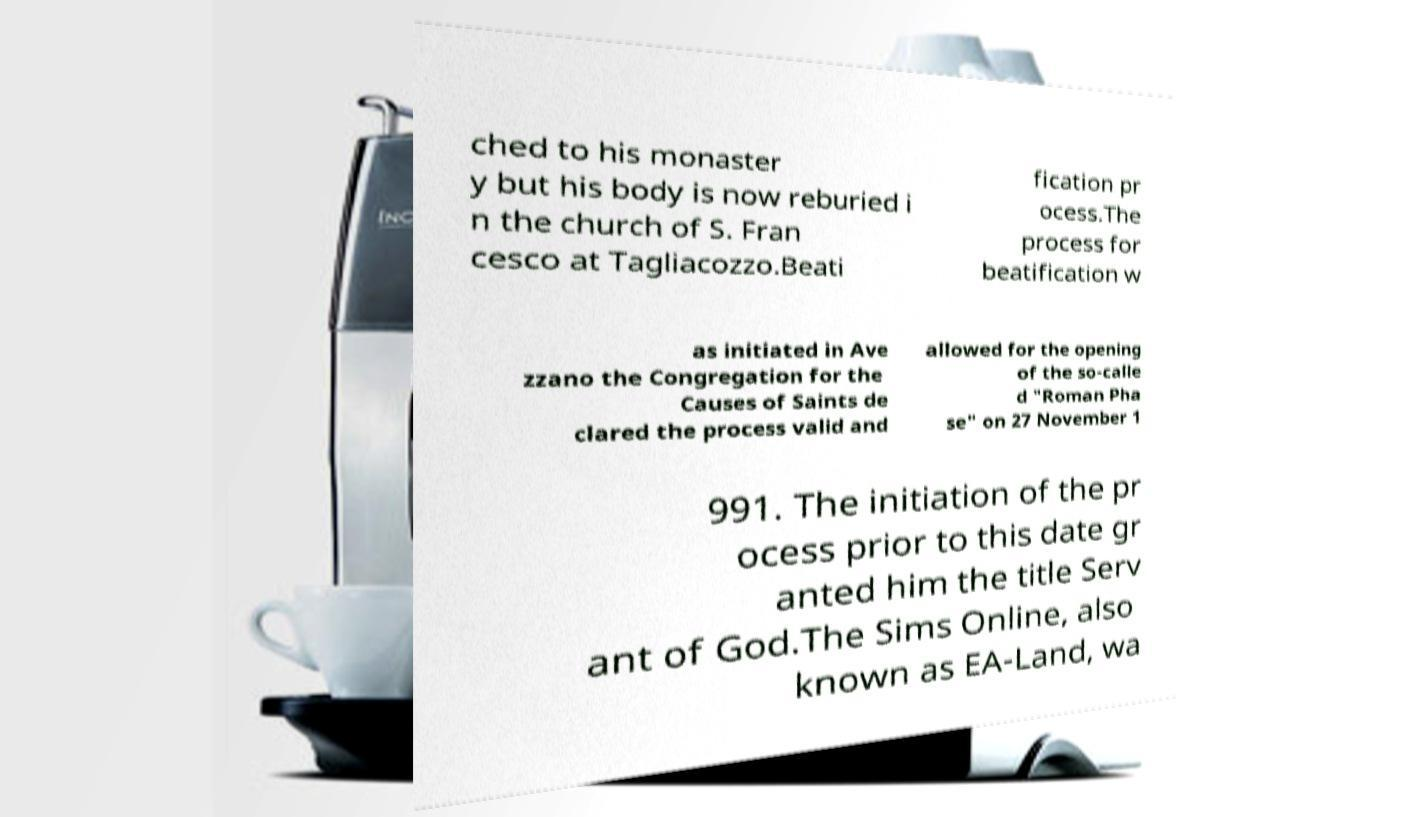I need the written content from this picture converted into text. Can you do that? ched to his monaster y but his body is now reburied i n the church of S. Fran cesco at Tagliacozzo.Beati fication pr ocess.The process for beatification w as initiated in Ave zzano the Congregation for the Causes of Saints de clared the process valid and allowed for the opening of the so-calle d "Roman Pha se" on 27 November 1 991. The initiation of the pr ocess prior to this date gr anted him the title Serv ant of God.The Sims Online, also known as EA-Land, wa 